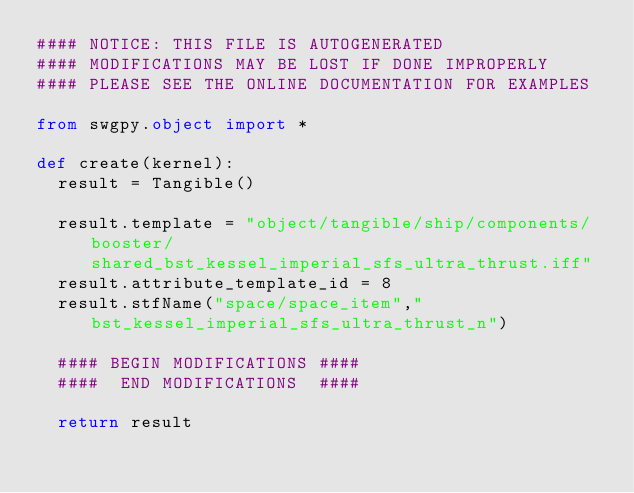<code> <loc_0><loc_0><loc_500><loc_500><_Python_>#### NOTICE: THIS FILE IS AUTOGENERATED
#### MODIFICATIONS MAY BE LOST IF DONE IMPROPERLY
#### PLEASE SEE THE ONLINE DOCUMENTATION FOR EXAMPLES

from swgpy.object import *	

def create(kernel):
	result = Tangible()

	result.template = "object/tangible/ship/components/booster/shared_bst_kessel_imperial_sfs_ultra_thrust.iff"
	result.attribute_template_id = 8
	result.stfName("space/space_item","bst_kessel_imperial_sfs_ultra_thrust_n")		
	
	#### BEGIN MODIFICATIONS ####
	####  END MODIFICATIONS  ####
	
	return result</code> 